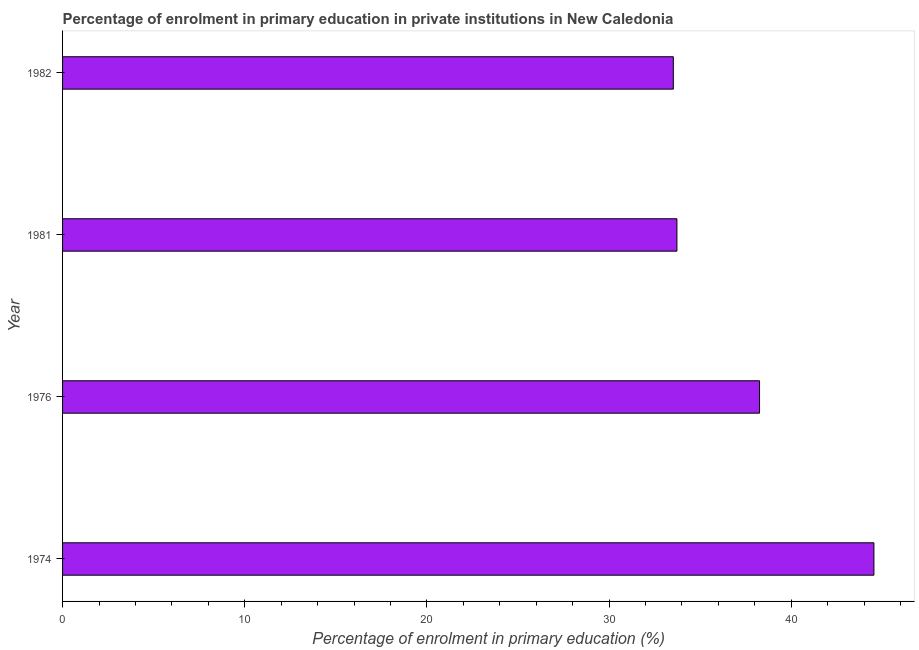Does the graph contain any zero values?
Provide a short and direct response. No. What is the title of the graph?
Provide a succinct answer. Percentage of enrolment in primary education in private institutions in New Caledonia. What is the label or title of the X-axis?
Keep it short and to the point. Percentage of enrolment in primary education (%). What is the enrolment percentage in primary education in 1976?
Your answer should be very brief. 38.26. Across all years, what is the maximum enrolment percentage in primary education?
Keep it short and to the point. 44.54. Across all years, what is the minimum enrolment percentage in primary education?
Give a very brief answer. 33.53. In which year was the enrolment percentage in primary education maximum?
Keep it short and to the point. 1974. In which year was the enrolment percentage in primary education minimum?
Offer a very short reply. 1982. What is the sum of the enrolment percentage in primary education?
Offer a terse response. 150.05. What is the difference between the enrolment percentage in primary education in 1974 and 1982?
Give a very brief answer. 11.01. What is the average enrolment percentage in primary education per year?
Offer a very short reply. 37.51. What is the median enrolment percentage in primary education?
Your answer should be compact. 35.99. What is the ratio of the enrolment percentage in primary education in 1974 to that in 1976?
Keep it short and to the point. 1.16. Is the enrolment percentage in primary education in 1976 less than that in 1982?
Give a very brief answer. No. What is the difference between the highest and the second highest enrolment percentage in primary education?
Offer a very short reply. 6.28. What is the difference between the highest and the lowest enrolment percentage in primary education?
Ensure brevity in your answer.  11.01. In how many years, is the enrolment percentage in primary education greater than the average enrolment percentage in primary education taken over all years?
Offer a terse response. 2. Are the values on the major ticks of X-axis written in scientific E-notation?
Keep it short and to the point. No. What is the Percentage of enrolment in primary education (%) of 1974?
Your answer should be compact. 44.54. What is the Percentage of enrolment in primary education (%) in 1976?
Make the answer very short. 38.26. What is the Percentage of enrolment in primary education (%) in 1981?
Keep it short and to the point. 33.72. What is the Percentage of enrolment in primary education (%) in 1982?
Your response must be concise. 33.53. What is the difference between the Percentage of enrolment in primary education (%) in 1974 and 1976?
Your response must be concise. 6.28. What is the difference between the Percentage of enrolment in primary education (%) in 1974 and 1981?
Give a very brief answer. 10.81. What is the difference between the Percentage of enrolment in primary education (%) in 1974 and 1982?
Your answer should be very brief. 11.01. What is the difference between the Percentage of enrolment in primary education (%) in 1976 and 1981?
Offer a very short reply. 4.54. What is the difference between the Percentage of enrolment in primary education (%) in 1976 and 1982?
Offer a very short reply. 4.73. What is the difference between the Percentage of enrolment in primary education (%) in 1981 and 1982?
Make the answer very short. 0.2. What is the ratio of the Percentage of enrolment in primary education (%) in 1974 to that in 1976?
Your answer should be very brief. 1.16. What is the ratio of the Percentage of enrolment in primary education (%) in 1974 to that in 1981?
Give a very brief answer. 1.32. What is the ratio of the Percentage of enrolment in primary education (%) in 1974 to that in 1982?
Your answer should be compact. 1.33. What is the ratio of the Percentage of enrolment in primary education (%) in 1976 to that in 1981?
Offer a very short reply. 1.13. What is the ratio of the Percentage of enrolment in primary education (%) in 1976 to that in 1982?
Offer a very short reply. 1.14. 